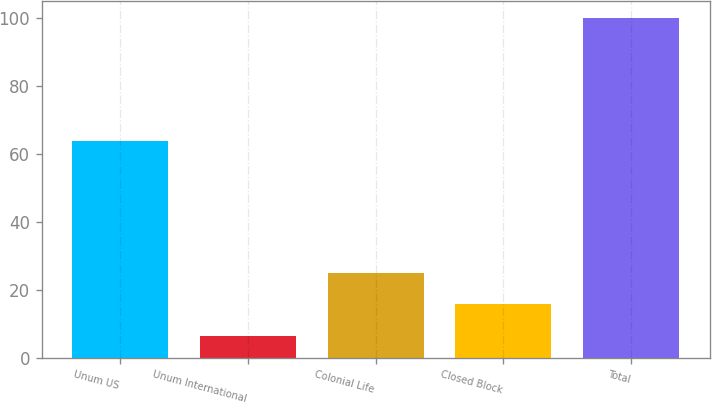<chart> <loc_0><loc_0><loc_500><loc_500><bar_chart><fcel>Unum US<fcel>Unum International<fcel>Colonial Life<fcel>Closed Block<fcel>Total<nl><fcel>63.8<fcel>6.3<fcel>25.04<fcel>15.67<fcel>100<nl></chart> 